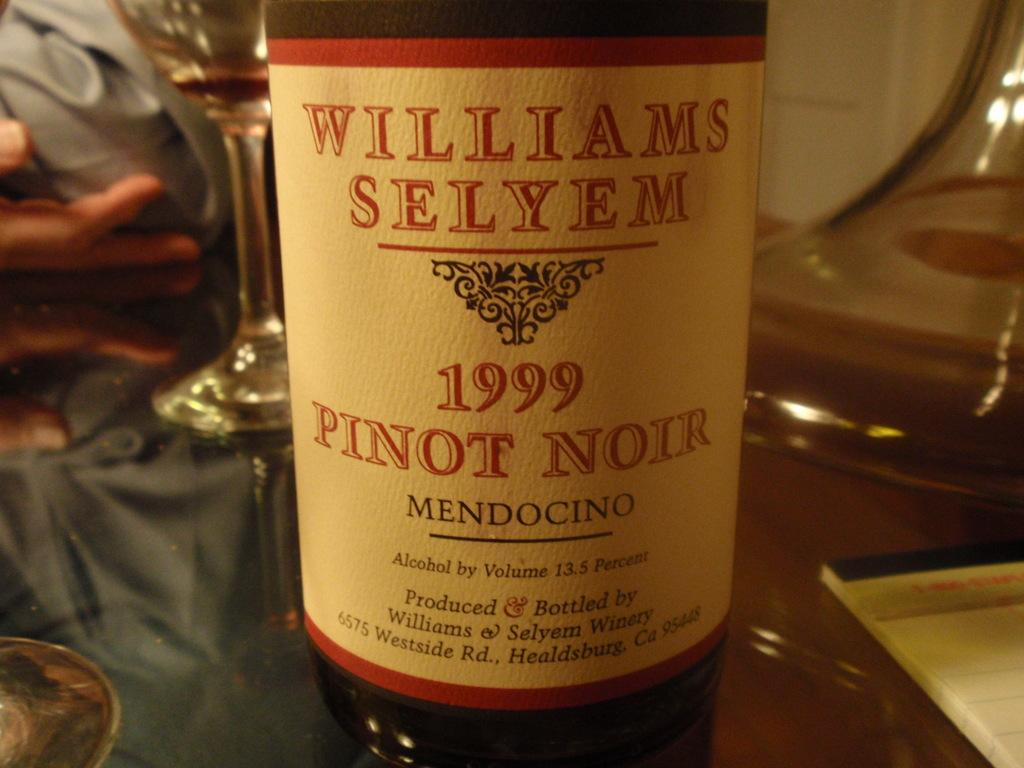What is the main object on the table in the image? There is a wine bottle in the image. What else can be seen on the table in the image? There are wine glasses and a cloth on the table in the image. Is there any reading material on the table in the image? Yes, there is a booklet on the table in the image. How many men are playing during recess in the image? There is no reference to men or recess in the image; it features a wine bottle, wine glasses, a cloth, and a booklet on a table. 